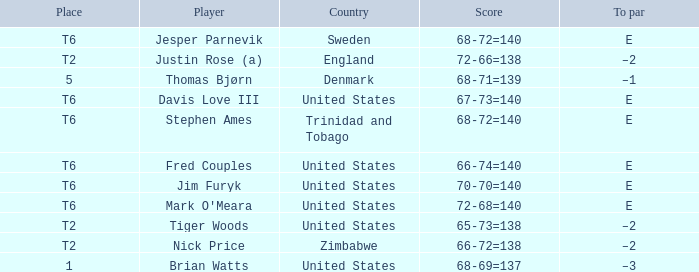What was the TO par for the player who scored 68-69=137? –3. 